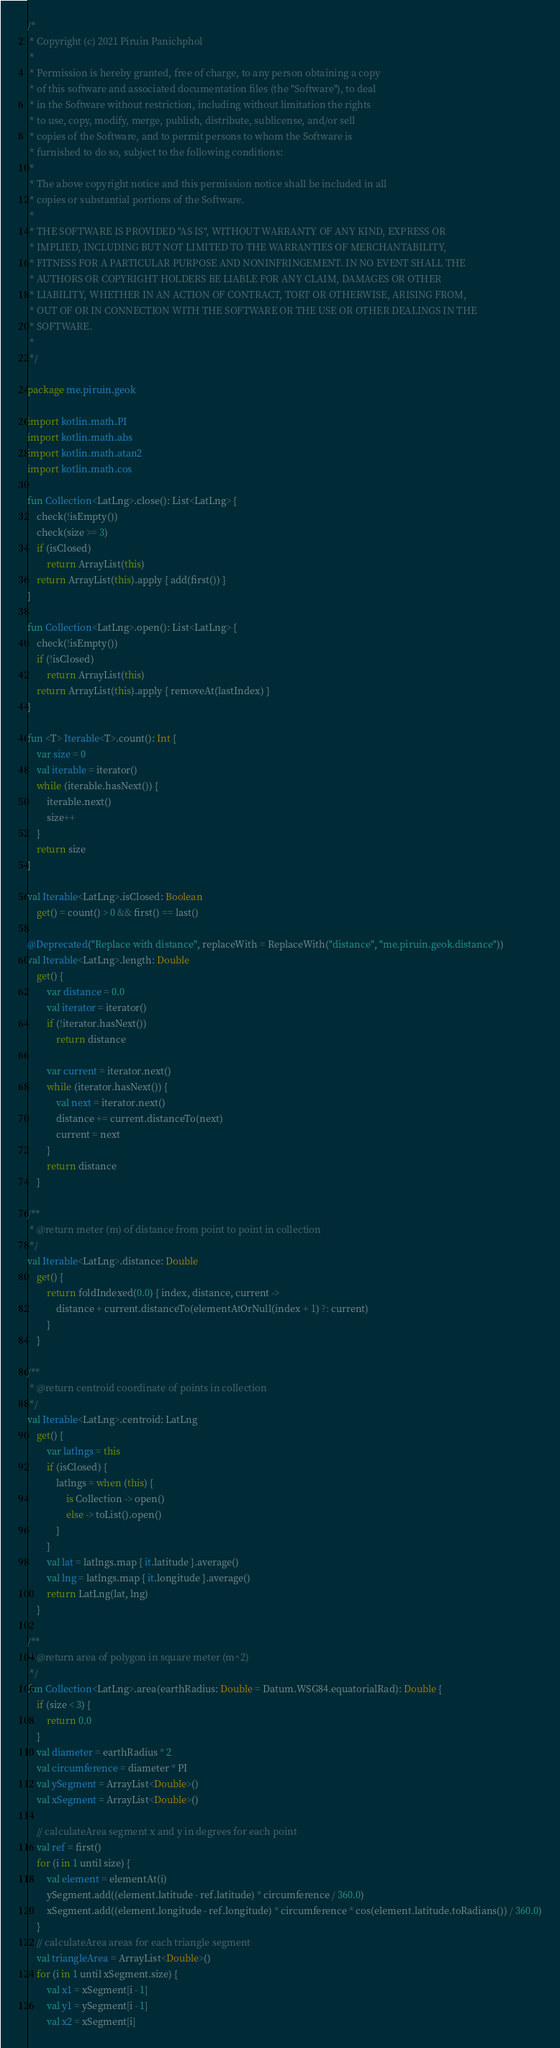<code> <loc_0><loc_0><loc_500><loc_500><_Kotlin_>/*
 * Copyright (c) 2021 Piruin Panichphol
 *
 * Permission is hereby granted, free of charge, to any person obtaining a copy
 * of this software and associated documentation files (the "Software"), to deal
 * in the Software without restriction, including without limitation the rights
 * to use, copy, modify, merge, publish, distribute, sublicense, and/or sell
 * copies of the Software, and to permit persons to whom the Software is
 * furnished to do so, subject to the following conditions:
 *
 * The above copyright notice and this permission notice shall be included in all
 * copies or substantial portions of the Software.
 *
 * THE SOFTWARE IS PROVIDED "AS IS", WITHOUT WARRANTY OF ANY KIND, EXPRESS OR
 * IMPLIED, INCLUDING BUT NOT LIMITED TO THE WARRANTIES OF MERCHANTABILITY,
 * FITNESS FOR A PARTICULAR PURPOSE AND NONINFRINGEMENT. IN NO EVENT SHALL THE
 * AUTHORS OR COPYRIGHT HOLDERS BE LIABLE FOR ANY CLAIM, DAMAGES OR OTHER
 * LIABILITY, WHETHER IN AN ACTION OF CONTRACT, TORT OR OTHERWISE, ARISING FROM,
 * OUT OF OR IN CONNECTION WITH THE SOFTWARE OR THE USE OR OTHER DEALINGS IN THE
 * SOFTWARE.
 *
 */

package me.piruin.geok

import kotlin.math.PI
import kotlin.math.abs
import kotlin.math.atan2
import kotlin.math.cos

fun Collection<LatLng>.close(): List<LatLng> {
    check(!isEmpty())
    check(size >= 3)
    if (isClosed)
        return ArrayList(this)
    return ArrayList(this).apply { add(first()) }
}

fun Collection<LatLng>.open(): List<LatLng> {
    check(!isEmpty())
    if (!isClosed)
        return ArrayList(this)
    return ArrayList(this).apply { removeAt(lastIndex) }
}

fun <T> Iterable<T>.count(): Int {
    var size = 0
    val iterable = iterator()
    while (iterable.hasNext()) {
        iterable.next()
        size++
    }
    return size
}

val Iterable<LatLng>.isClosed: Boolean
    get() = count() > 0 && first() == last()

@Deprecated("Replace with distance", replaceWith = ReplaceWith("distance", "me.piruin.geok.distance"))
val Iterable<LatLng>.length: Double
    get() {
        var distance = 0.0
        val iterator = iterator()
        if (!iterator.hasNext())
            return distance

        var current = iterator.next()
        while (iterator.hasNext()) {
            val next = iterator.next()
            distance += current.distanceTo(next)
            current = next
        }
        return distance
    }

/**
 * @return meter (m) of distance from point to point in collection
 */
val Iterable<LatLng>.distance: Double
    get() {
        return foldIndexed(0.0) { index, distance, current ->
            distance + current.distanceTo(elementAtOrNull(index + 1) ?: current)
        }
    }

/**
 * @return centroid coordinate of points in collection
 */
val Iterable<LatLng>.centroid: LatLng
    get() {
        var latlngs = this
        if (isClosed) {
            latlngs = when (this) {
                is Collection -> open()
                else -> toList().open()
            }
        }
        val lat = latlngs.map { it.latitude }.average()
        val lng = latlngs.map { it.longitude }.average()
        return LatLng(lat, lng)
    }

/**
 * @return area of polygon in square meter (m^2)
 */
fun Collection<LatLng>.area(earthRadius: Double = Datum.WSG84.equatorialRad): Double {
    if (size < 3) {
        return 0.0
    }
    val diameter = earthRadius * 2
    val circumference = diameter * PI
    val ySegment = ArrayList<Double>()
    val xSegment = ArrayList<Double>()

    // calculateArea segment x and y in degrees for each point
    val ref = first()
    for (i in 1 until size) {
        val element = elementAt(i)
        ySegment.add((element.latitude - ref.latitude) * circumference / 360.0)
        xSegment.add((element.longitude - ref.longitude) * circumference * cos(element.latitude.toRadians()) / 360.0)
    }
    // calculateArea areas for each triangle segment
    val triangleArea = ArrayList<Double>()
    for (i in 1 until xSegment.size) {
        val x1 = xSegment[i - 1]
        val y1 = ySegment[i - 1]
        val x2 = xSegment[i]</code> 